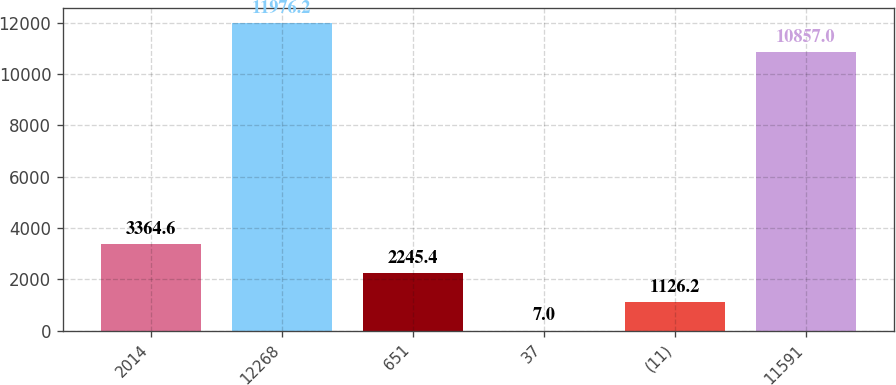<chart> <loc_0><loc_0><loc_500><loc_500><bar_chart><fcel>2014<fcel>12268<fcel>651<fcel>37<fcel>(11)<fcel>11591<nl><fcel>3364.6<fcel>11976.2<fcel>2245.4<fcel>7<fcel>1126.2<fcel>10857<nl></chart> 